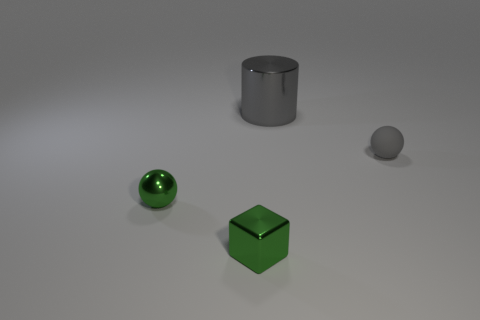There is a shiny thing that is the same color as the matte sphere; what is its size?
Your answer should be very brief. Large. The other matte object that is the same color as the large thing is what shape?
Your answer should be compact. Sphere. There is a small shiny object that is in front of the tiny green metal ball; are there any small metal blocks behind it?
Give a very brief answer. No. There is a ball on the left side of the tiny gray matte sphere; what is it made of?
Keep it short and to the point. Metal. Do the tiny gray thing and the gray shiny thing have the same shape?
Your response must be concise. No. There is a metal object in front of the tiny green thing to the left of the tiny metal object that is in front of the small shiny ball; what is its color?
Give a very brief answer. Green. How many green things have the same shape as the tiny gray object?
Offer a terse response. 1. There is a green shiny thing that is in front of the ball in front of the gray sphere; how big is it?
Offer a terse response. Small. Does the rubber thing have the same size as the green shiny cube?
Give a very brief answer. Yes. Are there any cylinders that are left of the tiny ball to the left of the gray thing that is to the left of the gray matte object?
Your answer should be very brief. No. 